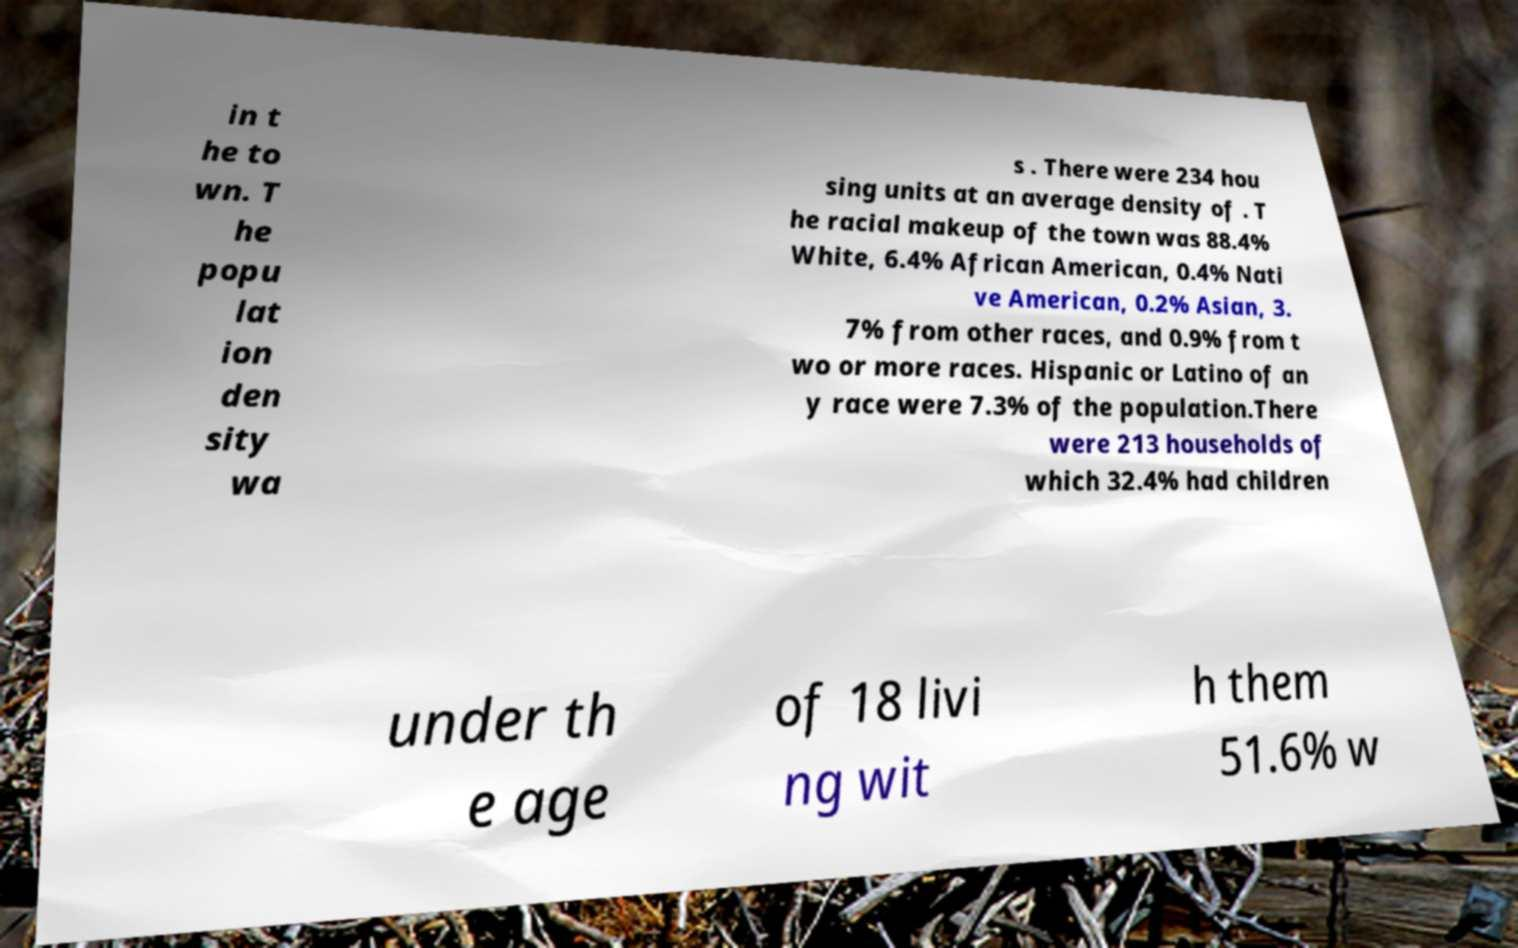What messages or text are displayed in this image? I need them in a readable, typed format. in t he to wn. T he popu lat ion den sity wa s . There were 234 hou sing units at an average density of . T he racial makeup of the town was 88.4% White, 6.4% African American, 0.4% Nati ve American, 0.2% Asian, 3. 7% from other races, and 0.9% from t wo or more races. Hispanic or Latino of an y race were 7.3% of the population.There were 213 households of which 32.4% had children under th e age of 18 livi ng wit h them 51.6% w 